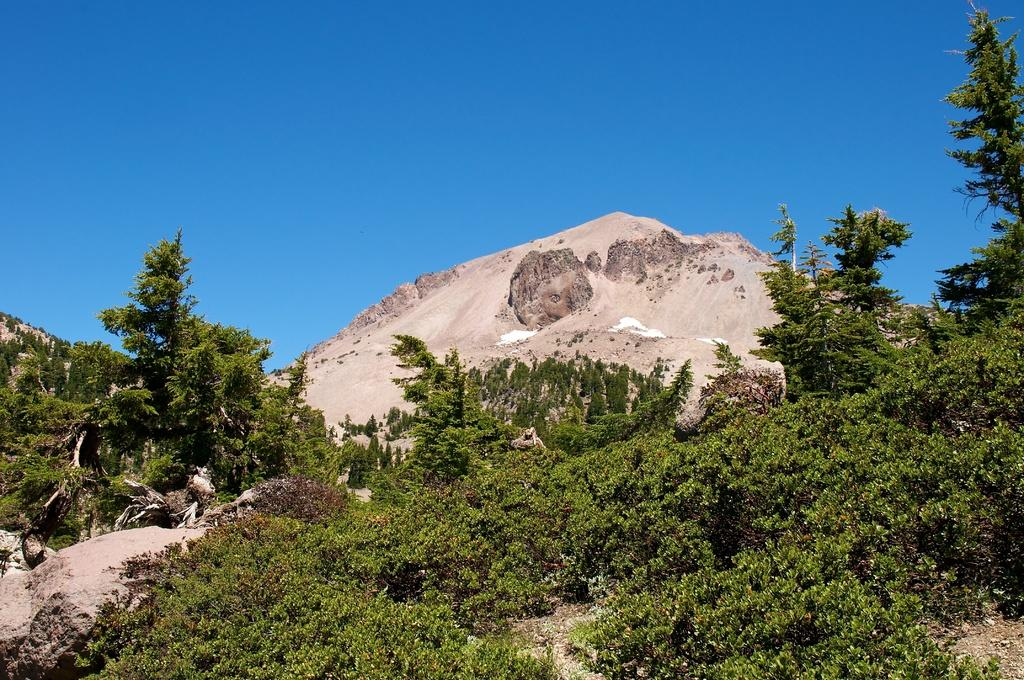What type of vegetation can be seen in the image? There are trees in the image. What geographical feature is present in the image? There is a mountain in the image. What is visible at the top of the image? The sky is visible at the top of the image. What type of smell can be detected from the trees in the image? There is no information about the smell of the trees in the image, as it is a visual medium. Can you hear the trees laughing in the image? Trees do not have the ability to laugh, and there is no sound in the image. 